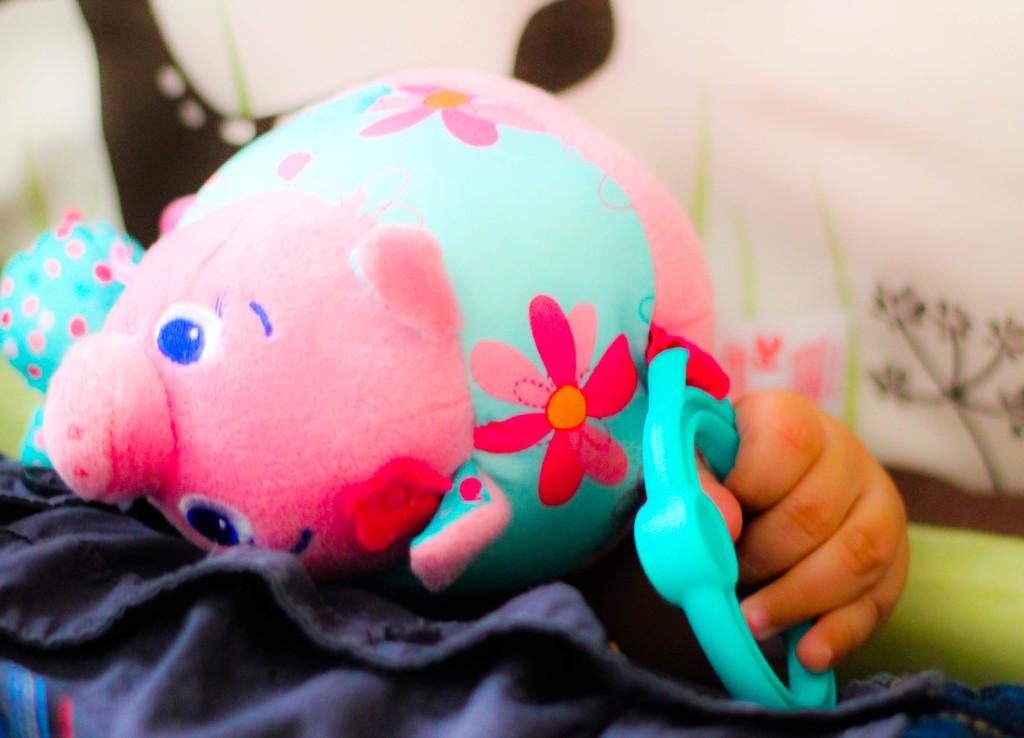Who or what is the main subject in the center of the image? There is a person in the center of the image. What is the person holding in the image? The person is holding a soft toy. Can you describe the background of the image? There is a cloth visible in the background of the image. What type of celery can be seen growing in the background of the image? There is no celery present in the image; it features a person holding a soft toy with a cloth visible in the background. 